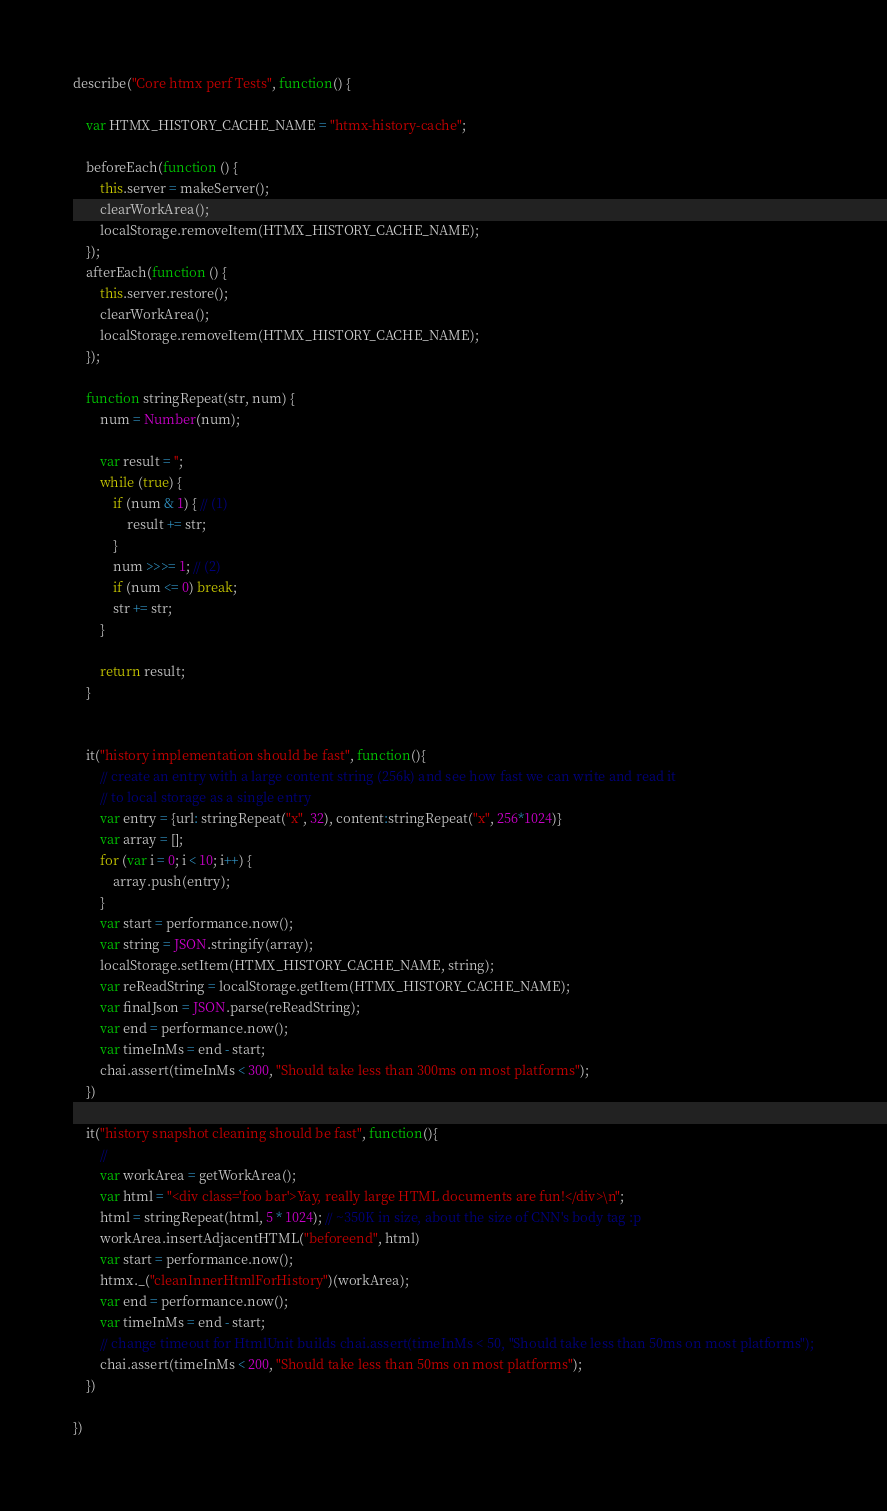<code> <loc_0><loc_0><loc_500><loc_500><_JavaScript_>describe("Core htmx perf Tests", function() {

    var HTMX_HISTORY_CACHE_NAME = "htmx-history-cache";

    beforeEach(function () {
        this.server = makeServer();
        clearWorkArea();
        localStorage.removeItem(HTMX_HISTORY_CACHE_NAME);
    });
    afterEach(function () {
        this.server.restore();
        clearWorkArea();
        localStorage.removeItem(HTMX_HISTORY_CACHE_NAME);
    });

    function stringRepeat(str, num) {
        num = Number(num);

        var result = '';
        while (true) {
            if (num & 1) { // (1)
                result += str;
            }
            num >>>= 1; // (2)
            if (num <= 0) break;
            str += str;
        }

        return result;
    }


    it("history implementation should be fast", function(){
        // create an entry with a large content string (256k) and see how fast we can write and read it
        // to local storage as a single entry
        var entry = {url: stringRepeat("x", 32), content:stringRepeat("x", 256*1024)}
        var array = [];
        for (var i = 0; i < 10; i++) {
            array.push(entry);
        }
        var start = performance.now();
        var string = JSON.stringify(array);
        localStorage.setItem(HTMX_HISTORY_CACHE_NAME, string);
        var reReadString = localStorage.getItem(HTMX_HISTORY_CACHE_NAME);
        var finalJson = JSON.parse(reReadString);
        var end = performance.now();
        var timeInMs = end - start;
        chai.assert(timeInMs < 300, "Should take less than 300ms on most platforms");
    })

    it("history snapshot cleaning should be fast", function(){
        //
        var workArea = getWorkArea();
        var html = "<div class='foo bar'>Yay, really large HTML documents are fun!</div>\n";
        html = stringRepeat(html, 5 * 1024); // ~350K in size, about the size of CNN's body tag :p
        workArea.insertAdjacentHTML("beforeend", html)
        var start = performance.now();
        htmx._("cleanInnerHtmlForHistory")(workArea);
        var end = performance.now();
        var timeInMs = end - start;
        // change timeout for HtmlUnit builds chai.assert(timeInMs < 50, "Should take less than 50ms on most platforms");
        chai.assert(timeInMs < 200, "Should take less than 50ms on most platforms");
    })

})</code> 